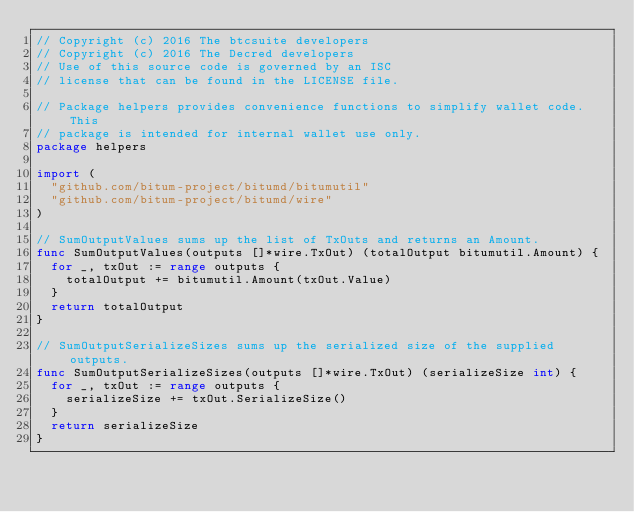Convert code to text. <code><loc_0><loc_0><loc_500><loc_500><_Go_>// Copyright (c) 2016 The btcsuite developers
// Copyright (c) 2016 The Decred developers
// Use of this source code is governed by an ISC
// license that can be found in the LICENSE file.

// Package helpers provides convenience functions to simplify wallet code.  This
// package is intended for internal wallet use only.
package helpers

import (
	"github.com/bitum-project/bitumd/bitumutil"
	"github.com/bitum-project/bitumd/wire"
)

// SumOutputValues sums up the list of TxOuts and returns an Amount.
func SumOutputValues(outputs []*wire.TxOut) (totalOutput bitumutil.Amount) {
	for _, txOut := range outputs {
		totalOutput += bitumutil.Amount(txOut.Value)
	}
	return totalOutput
}

// SumOutputSerializeSizes sums up the serialized size of the supplied outputs.
func SumOutputSerializeSizes(outputs []*wire.TxOut) (serializeSize int) {
	for _, txOut := range outputs {
		serializeSize += txOut.SerializeSize()
	}
	return serializeSize
}
</code> 